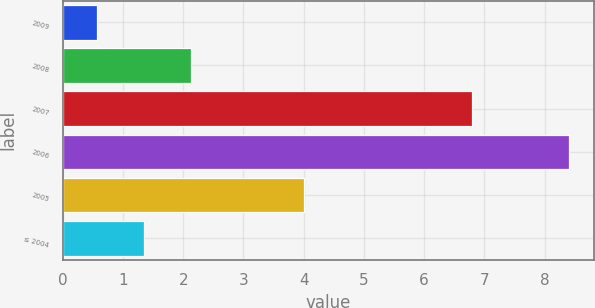<chart> <loc_0><loc_0><loc_500><loc_500><bar_chart><fcel>2009<fcel>2008<fcel>2007<fcel>2006<fcel>2005<fcel>≤ 2004<nl><fcel>0.57<fcel>2.13<fcel>6.8<fcel>8.4<fcel>4<fcel>1.35<nl></chart> 